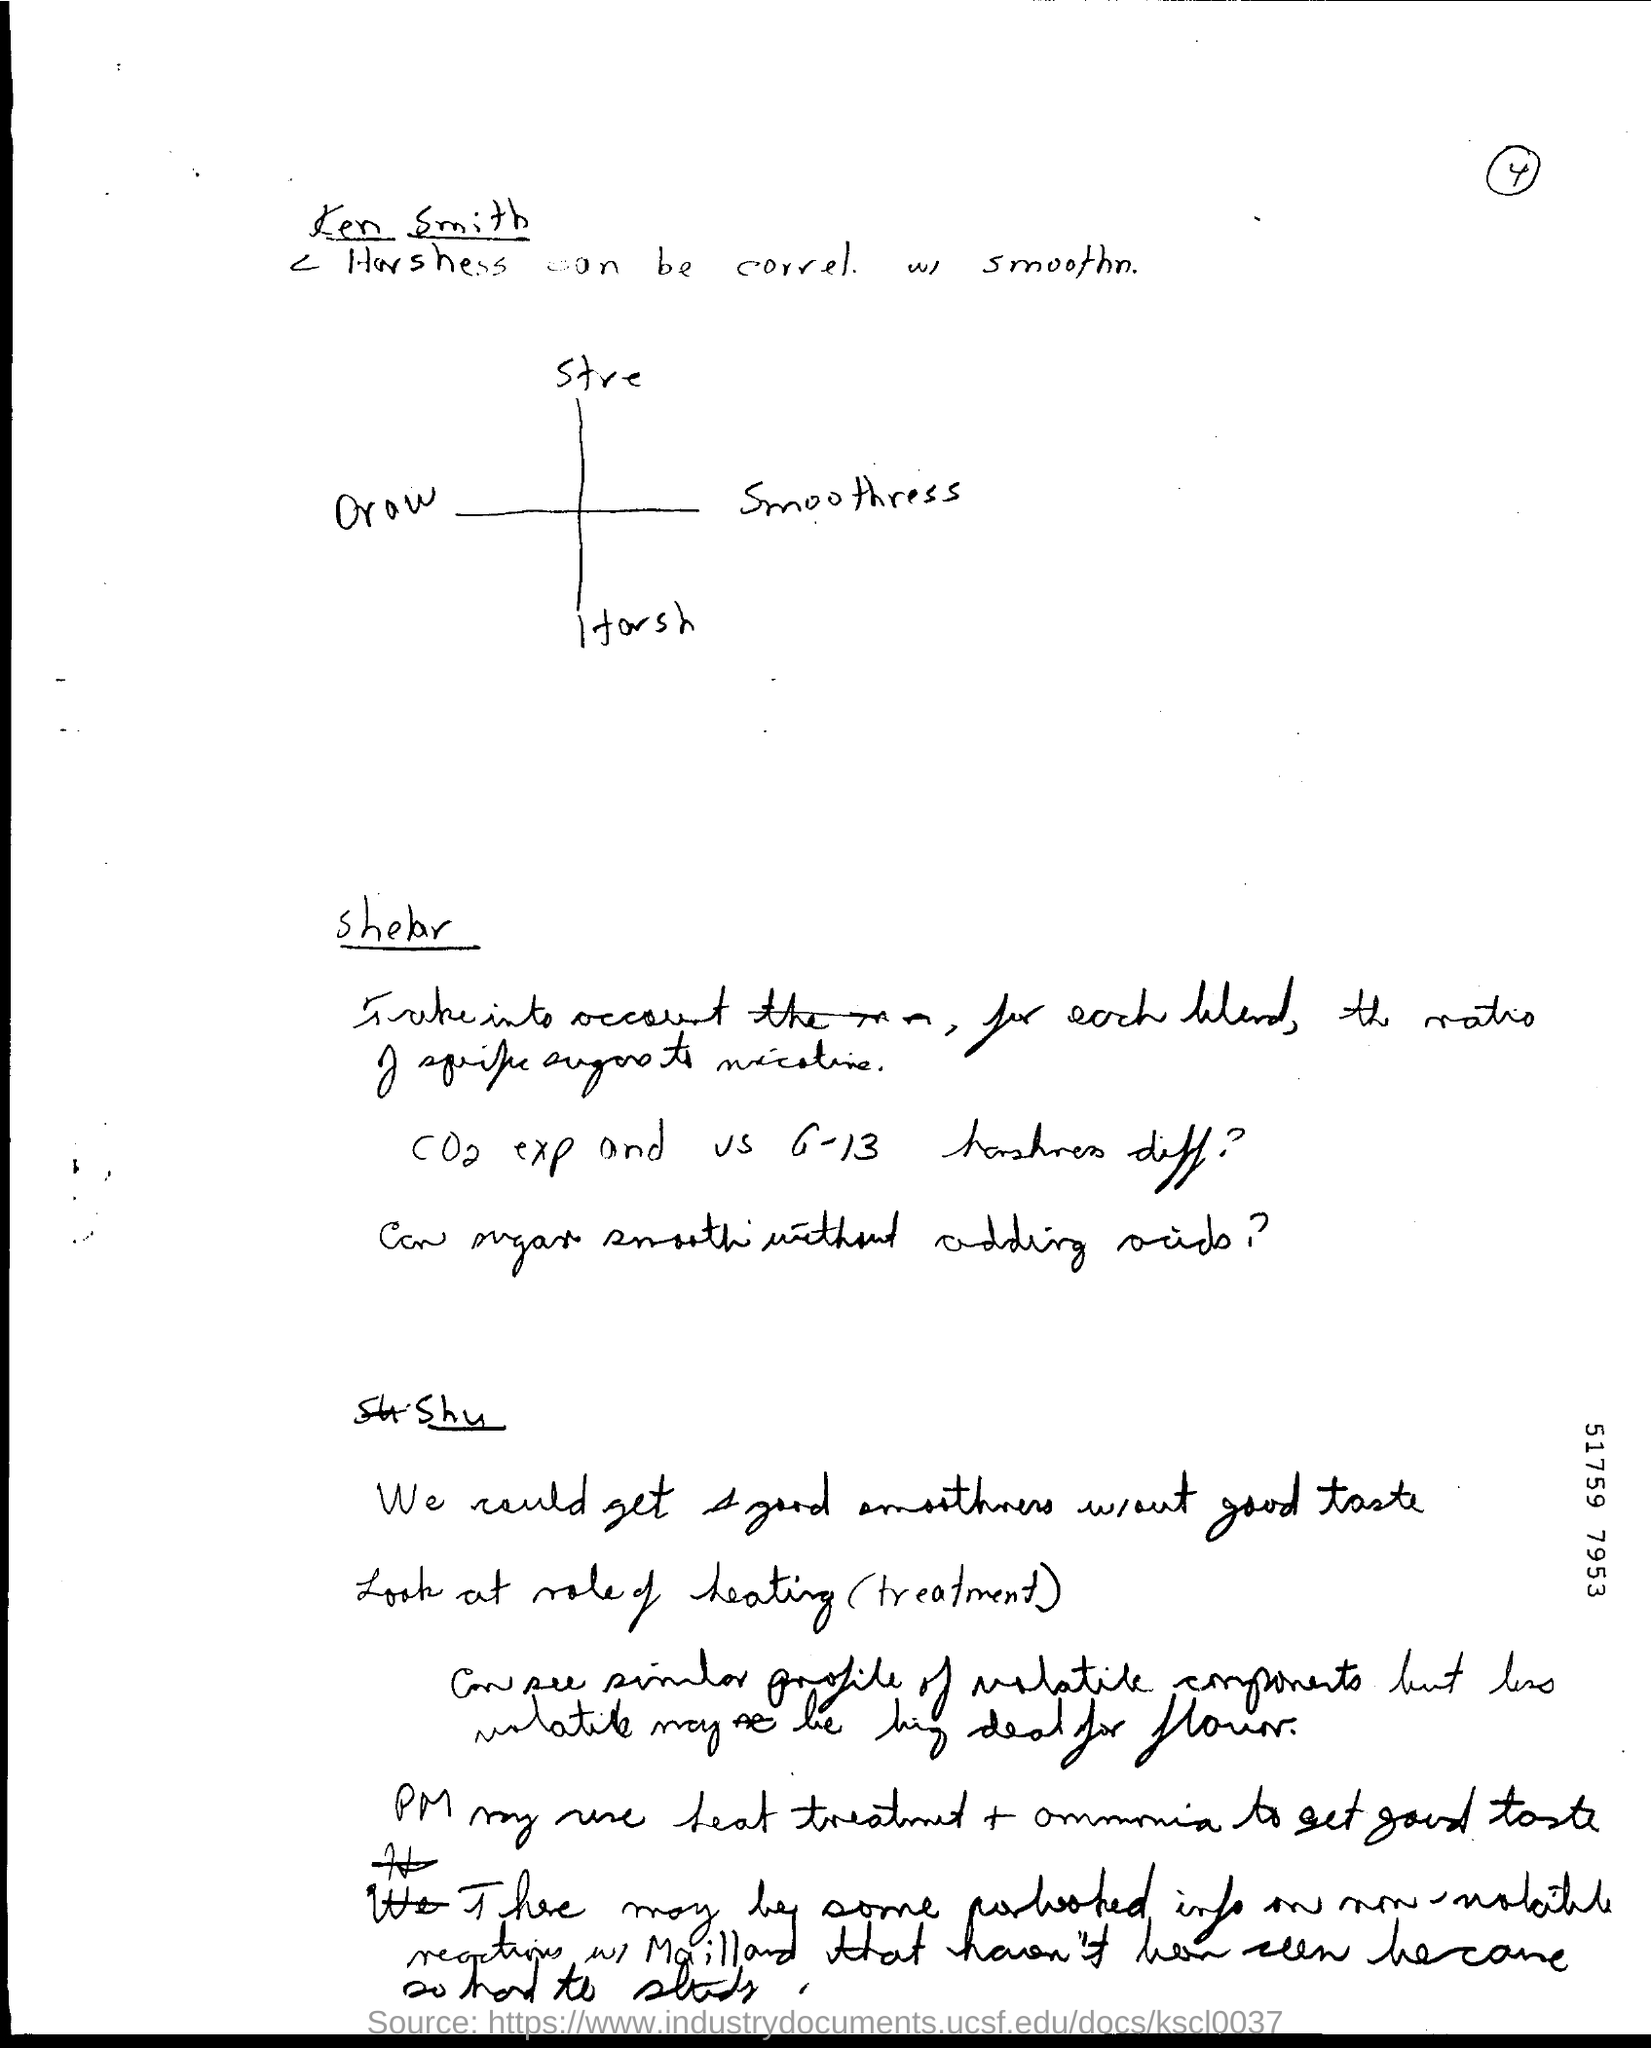What is the first side heading given?
Your answer should be very brief. Ken Smith. 